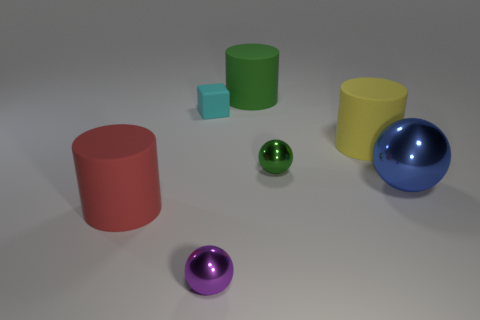Subtract all large spheres. How many spheres are left? 2 Add 1 large blue shiny spheres. How many objects exist? 8 Subtract all green balls. How many balls are left? 2 Subtract 2 spheres. How many spheres are left? 1 Subtract all balls. How many objects are left? 4 Subtract all purple spheres. Subtract all cyan cylinders. How many spheres are left? 2 Subtract all blue blocks. How many red cylinders are left? 1 Subtract all tiny green spheres. Subtract all cyan rubber cubes. How many objects are left? 5 Add 1 large green cylinders. How many large green cylinders are left? 2 Add 1 blue metal cylinders. How many blue metal cylinders exist? 1 